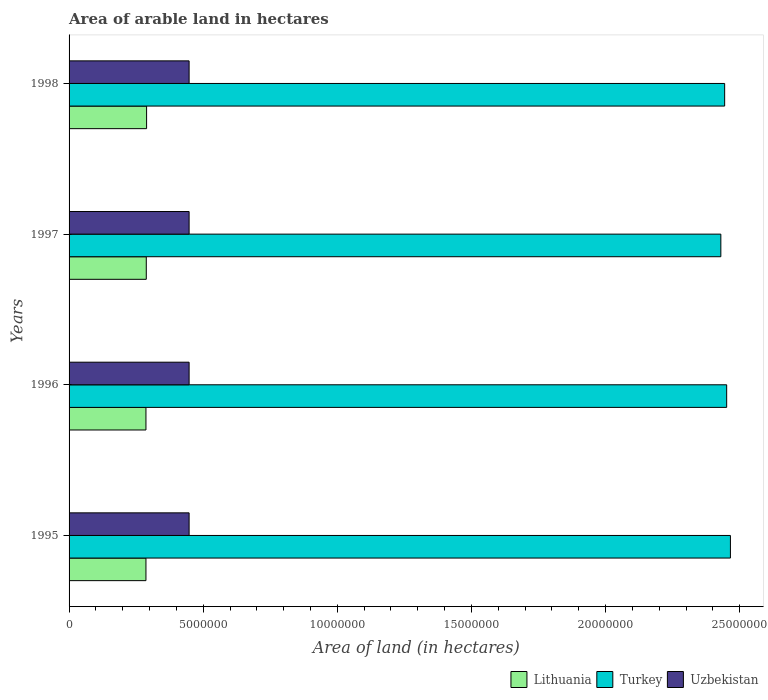How many groups of bars are there?
Ensure brevity in your answer.  4. Are the number of bars per tick equal to the number of legend labels?
Make the answer very short. Yes. How many bars are there on the 2nd tick from the top?
Your response must be concise. 3. In how many cases, is the number of bars for a given year not equal to the number of legend labels?
Make the answer very short. 0. What is the total arable land in Uzbekistan in 1996?
Keep it short and to the point. 4.48e+06. Across all years, what is the maximum total arable land in Lithuania?
Provide a succinct answer. 2.89e+06. Across all years, what is the minimum total arable land in Turkey?
Keep it short and to the point. 2.43e+07. In which year was the total arable land in Uzbekistan maximum?
Offer a terse response. 1995. What is the total total arable land in Lithuania in the graph?
Your answer should be very brief. 1.15e+07. What is the difference between the total arable land in Lithuania in 1995 and that in 1996?
Offer a terse response. 0. What is the difference between the total arable land in Uzbekistan in 1997 and the total arable land in Turkey in 1998?
Keep it short and to the point. -2.00e+07. What is the average total arable land in Uzbekistan per year?
Ensure brevity in your answer.  4.48e+06. In the year 1997, what is the difference between the total arable land in Turkey and total arable land in Uzbekistan?
Give a very brief answer. 1.98e+07. In how many years, is the total arable land in Uzbekistan greater than 12000000 hectares?
Your response must be concise. 0. What is the ratio of the total arable land in Lithuania in 1996 to that in 1997?
Offer a terse response. 1. Is the total arable land in Lithuania in 1995 less than that in 1998?
Ensure brevity in your answer.  Yes. What is the difference between the highest and the second highest total arable land in Lithuania?
Keep it short and to the point. 1.20e+04. Is the sum of the total arable land in Uzbekistan in 1995 and 1997 greater than the maximum total arable land in Turkey across all years?
Offer a terse response. No. What does the 1st bar from the top in 1996 represents?
Your answer should be compact. Uzbekistan. What does the 1st bar from the bottom in 1998 represents?
Provide a short and direct response. Lithuania. Is it the case that in every year, the sum of the total arable land in Uzbekistan and total arable land in Turkey is greater than the total arable land in Lithuania?
Keep it short and to the point. Yes. How many bars are there?
Keep it short and to the point. 12. How many years are there in the graph?
Keep it short and to the point. 4. Does the graph contain any zero values?
Offer a terse response. No. Where does the legend appear in the graph?
Your answer should be very brief. Bottom right. How are the legend labels stacked?
Your response must be concise. Horizontal. What is the title of the graph?
Offer a very short reply. Area of arable land in hectares. Does "Ireland" appear as one of the legend labels in the graph?
Make the answer very short. No. What is the label or title of the X-axis?
Ensure brevity in your answer.  Area of land (in hectares). What is the label or title of the Y-axis?
Your response must be concise. Years. What is the Area of land (in hectares) in Lithuania in 1995?
Provide a short and direct response. 2.87e+06. What is the Area of land (in hectares) in Turkey in 1995?
Offer a terse response. 2.47e+07. What is the Area of land (in hectares) in Uzbekistan in 1995?
Ensure brevity in your answer.  4.48e+06. What is the Area of land (in hectares) in Lithuania in 1996?
Make the answer very short. 2.87e+06. What is the Area of land (in hectares) in Turkey in 1996?
Keep it short and to the point. 2.45e+07. What is the Area of land (in hectares) of Uzbekistan in 1996?
Offer a very short reply. 4.48e+06. What is the Area of land (in hectares) of Lithuania in 1997?
Keep it short and to the point. 2.88e+06. What is the Area of land (in hectares) in Turkey in 1997?
Offer a very short reply. 2.43e+07. What is the Area of land (in hectares) of Uzbekistan in 1997?
Give a very brief answer. 4.48e+06. What is the Area of land (in hectares) in Lithuania in 1998?
Your response must be concise. 2.89e+06. What is the Area of land (in hectares) in Turkey in 1998?
Your answer should be compact. 2.44e+07. What is the Area of land (in hectares) in Uzbekistan in 1998?
Your response must be concise. 4.48e+06. Across all years, what is the maximum Area of land (in hectares) of Lithuania?
Offer a terse response. 2.89e+06. Across all years, what is the maximum Area of land (in hectares) of Turkey?
Give a very brief answer. 2.47e+07. Across all years, what is the maximum Area of land (in hectares) in Uzbekistan?
Ensure brevity in your answer.  4.48e+06. Across all years, what is the minimum Area of land (in hectares) in Lithuania?
Your answer should be very brief. 2.87e+06. Across all years, what is the minimum Area of land (in hectares) of Turkey?
Give a very brief answer. 2.43e+07. Across all years, what is the minimum Area of land (in hectares) of Uzbekistan?
Your response must be concise. 4.48e+06. What is the total Area of land (in hectares) in Lithuania in the graph?
Offer a terse response. 1.15e+07. What is the total Area of land (in hectares) of Turkey in the graph?
Provide a succinct answer. 9.79e+07. What is the total Area of land (in hectares) of Uzbekistan in the graph?
Your answer should be compact. 1.79e+07. What is the difference between the Area of land (in hectares) of Turkey in 1995 and that in 1996?
Ensure brevity in your answer.  1.40e+05. What is the difference between the Area of land (in hectares) of Uzbekistan in 1995 and that in 1996?
Ensure brevity in your answer.  0. What is the difference between the Area of land (in hectares) in Lithuania in 1995 and that in 1997?
Provide a succinct answer. -1.20e+04. What is the difference between the Area of land (in hectares) in Turkey in 1995 and that in 1997?
Your answer should be very brief. 3.57e+05. What is the difference between the Area of land (in hectares) in Uzbekistan in 1995 and that in 1997?
Your response must be concise. 0. What is the difference between the Area of land (in hectares) of Lithuania in 1995 and that in 1998?
Your response must be concise. -2.40e+04. What is the difference between the Area of land (in hectares) in Turkey in 1995 and that in 1998?
Your answer should be very brief. 2.15e+05. What is the difference between the Area of land (in hectares) of Lithuania in 1996 and that in 1997?
Your answer should be very brief. -1.20e+04. What is the difference between the Area of land (in hectares) in Turkey in 1996 and that in 1997?
Your answer should be very brief. 2.17e+05. What is the difference between the Area of land (in hectares) of Lithuania in 1996 and that in 1998?
Offer a very short reply. -2.40e+04. What is the difference between the Area of land (in hectares) of Turkey in 1996 and that in 1998?
Your answer should be compact. 7.50e+04. What is the difference between the Area of land (in hectares) in Lithuania in 1997 and that in 1998?
Your response must be concise. -1.20e+04. What is the difference between the Area of land (in hectares) of Turkey in 1997 and that in 1998?
Make the answer very short. -1.42e+05. What is the difference between the Area of land (in hectares) of Lithuania in 1995 and the Area of land (in hectares) of Turkey in 1996?
Offer a very short reply. -2.16e+07. What is the difference between the Area of land (in hectares) in Lithuania in 1995 and the Area of land (in hectares) in Uzbekistan in 1996?
Your answer should be compact. -1.61e+06. What is the difference between the Area of land (in hectares) of Turkey in 1995 and the Area of land (in hectares) of Uzbekistan in 1996?
Ensure brevity in your answer.  2.02e+07. What is the difference between the Area of land (in hectares) of Lithuania in 1995 and the Area of land (in hectares) of Turkey in 1997?
Your response must be concise. -2.14e+07. What is the difference between the Area of land (in hectares) of Lithuania in 1995 and the Area of land (in hectares) of Uzbekistan in 1997?
Offer a very short reply. -1.61e+06. What is the difference between the Area of land (in hectares) of Turkey in 1995 and the Area of land (in hectares) of Uzbekistan in 1997?
Provide a short and direct response. 2.02e+07. What is the difference between the Area of land (in hectares) in Lithuania in 1995 and the Area of land (in hectares) in Turkey in 1998?
Your answer should be very brief. -2.16e+07. What is the difference between the Area of land (in hectares) of Lithuania in 1995 and the Area of land (in hectares) of Uzbekistan in 1998?
Provide a short and direct response. -1.61e+06. What is the difference between the Area of land (in hectares) of Turkey in 1995 and the Area of land (in hectares) of Uzbekistan in 1998?
Your response must be concise. 2.02e+07. What is the difference between the Area of land (in hectares) of Lithuania in 1996 and the Area of land (in hectares) of Turkey in 1997?
Provide a succinct answer. -2.14e+07. What is the difference between the Area of land (in hectares) of Lithuania in 1996 and the Area of land (in hectares) of Uzbekistan in 1997?
Make the answer very short. -1.61e+06. What is the difference between the Area of land (in hectares) of Turkey in 1996 and the Area of land (in hectares) of Uzbekistan in 1997?
Offer a terse response. 2.00e+07. What is the difference between the Area of land (in hectares) in Lithuania in 1996 and the Area of land (in hectares) in Turkey in 1998?
Your response must be concise. -2.16e+07. What is the difference between the Area of land (in hectares) of Lithuania in 1996 and the Area of land (in hectares) of Uzbekistan in 1998?
Keep it short and to the point. -1.61e+06. What is the difference between the Area of land (in hectares) in Turkey in 1996 and the Area of land (in hectares) in Uzbekistan in 1998?
Ensure brevity in your answer.  2.00e+07. What is the difference between the Area of land (in hectares) in Lithuania in 1997 and the Area of land (in hectares) in Turkey in 1998?
Provide a succinct answer. -2.16e+07. What is the difference between the Area of land (in hectares) in Lithuania in 1997 and the Area of land (in hectares) in Uzbekistan in 1998?
Keep it short and to the point. -1.60e+06. What is the difference between the Area of land (in hectares) of Turkey in 1997 and the Area of land (in hectares) of Uzbekistan in 1998?
Your answer should be compact. 1.98e+07. What is the average Area of land (in hectares) of Lithuania per year?
Offer a very short reply. 2.88e+06. What is the average Area of land (in hectares) in Turkey per year?
Ensure brevity in your answer.  2.45e+07. What is the average Area of land (in hectares) in Uzbekistan per year?
Your answer should be compact. 4.48e+06. In the year 1995, what is the difference between the Area of land (in hectares) of Lithuania and Area of land (in hectares) of Turkey?
Your response must be concise. -2.18e+07. In the year 1995, what is the difference between the Area of land (in hectares) of Lithuania and Area of land (in hectares) of Uzbekistan?
Provide a succinct answer. -1.61e+06. In the year 1995, what is the difference between the Area of land (in hectares) of Turkey and Area of land (in hectares) of Uzbekistan?
Provide a succinct answer. 2.02e+07. In the year 1996, what is the difference between the Area of land (in hectares) of Lithuania and Area of land (in hectares) of Turkey?
Ensure brevity in your answer.  -2.16e+07. In the year 1996, what is the difference between the Area of land (in hectares) of Lithuania and Area of land (in hectares) of Uzbekistan?
Offer a terse response. -1.61e+06. In the year 1996, what is the difference between the Area of land (in hectares) of Turkey and Area of land (in hectares) of Uzbekistan?
Offer a very short reply. 2.00e+07. In the year 1997, what is the difference between the Area of land (in hectares) of Lithuania and Area of land (in hectares) of Turkey?
Make the answer very short. -2.14e+07. In the year 1997, what is the difference between the Area of land (in hectares) in Lithuania and Area of land (in hectares) in Uzbekistan?
Your answer should be very brief. -1.60e+06. In the year 1997, what is the difference between the Area of land (in hectares) in Turkey and Area of land (in hectares) in Uzbekistan?
Provide a succinct answer. 1.98e+07. In the year 1998, what is the difference between the Area of land (in hectares) in Lithuania and Area of land (in hectares) in Turkey?
Offer a terse response. -2.15e+07. In the year 1998, what is the difference between the Area of land (in hectares) in Lithuania and Area of land (in hectares) in Uzbekistan?
Offer a very short reply. -1.58e+06. In the year 1998, what is the difference between the Area of land (in hectares) in Turkey and Area of land (in hectares) in Uzbekistan?
Make the answer very short. 2.00e+07. What is the ratio of the Area of land (in hectares) of Uzbekistan in 1995 to that in 1996?
Provide a succinct answer. 1. What is the ratio of the Area of land (in hectares) in Lithuania in 1995 to that in 1997?
Offer a terse response. 1. What is the ratio of the Area of land (in hectares) in Turkey in 1995 to that in 1997?
Offer a terse response. 1.01. What is the ratio of the Area of land (in hectares) of Lithuania in 1995 to that in 1998?
Offer a terse response. 0.99. What is the ratio of the Area of land (in hectares) in Turkey in 1995 to that in 1998?
Offer a very short reply. 1.01. What is the ratio of the Area of land (in hectares) in Uzbekistan in 1995 to that in 1998?
Ensure brevity in your answer.  1. What is the ratio of the Area of land (in hectares) in Turkey in 1996 to that in 1997?
Make the answer very short. 1.01. What is the ratio of the Area of land (in hectares) in Turkey in 1996 to that in 1998?
Give a very brief answer. 1. What is the ratio of the Area of land (in hectares) in Turkey in 1997 to that in 1998?
Offer a terse response. 0.99. What is the ratio of the Area of land (in hectares) in Uzbekistan in 1997 to that in 1998?
Provide a short and direct response. 1. What is the difference between the highest and the second highest Area of land (in hectares) in Lithuania?
Your answer should be compact. 1.20e+04. What is the difference between the highest and the second highest Area of land (in hectares) in Turkey?
Keep it short and to the point. 1.40e+05. What is the difference between the highest and the second highest Area of land (in hectares) of Uzbekistan?
Offer a terse response. 0. What is the difference between the highest and the lowest Area of land (in hectares) in Lithuania?
Offer a terse response. 2.40e+04. What is the difference between the highest and the lowest Area of land (in hectares) of Turkey?
Make the answer very short. 3.57e+05. 